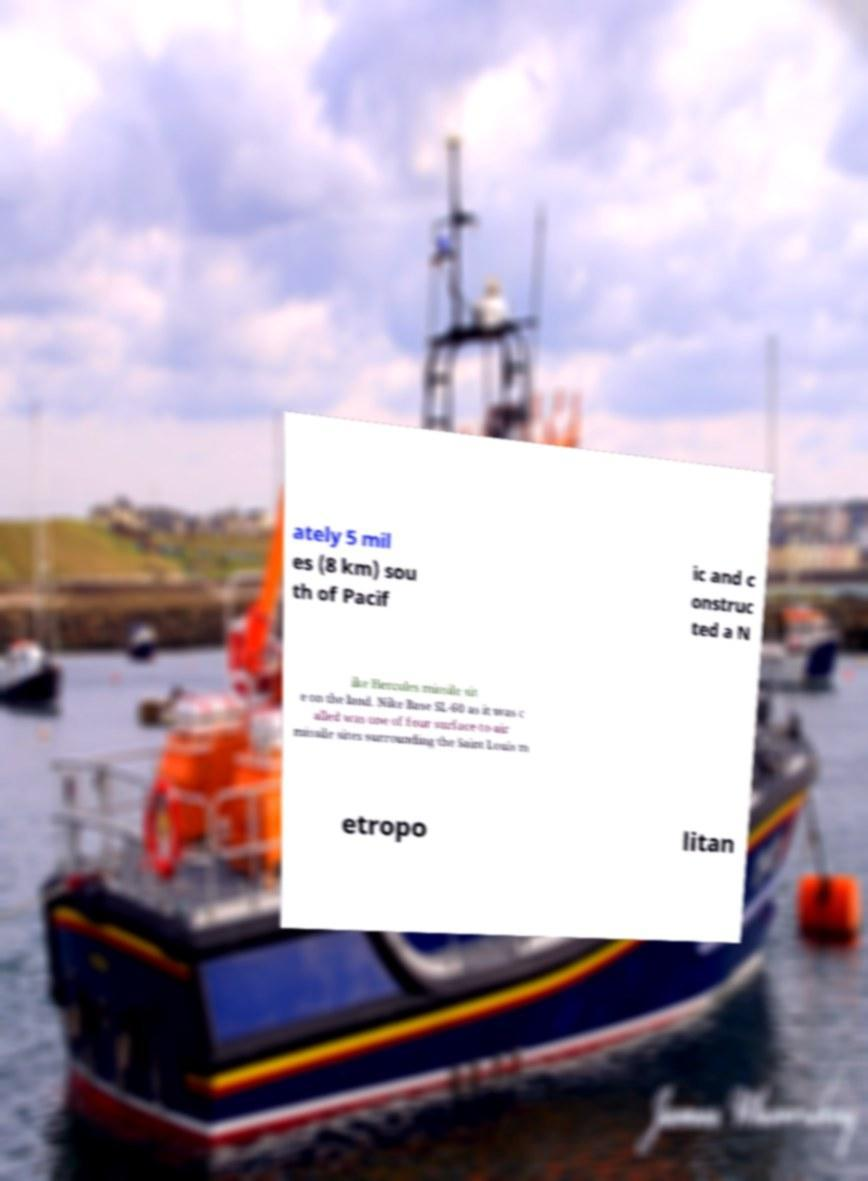Can you read and provide the text displayed in the image?This photo seems to have some interesting text. Can you extract and type it out for me? ately 5 mil es (8 km) sou th of Pacif ic and c onstruc ted a N ike Hercules missile sit e on the land. Nike Base SL-60 as it was c alled was one of four surface-to-air missile sites surrounding the Saint Louis m etropo litan 